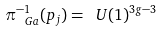<formula> <loc_0><loc_0><loc_500><loc_500>\pi _ { \ G a } ^ { - 1 } ( p _ { j } ) = \ U ( 1 ) ^ { 3 g - 3 }</formula> 